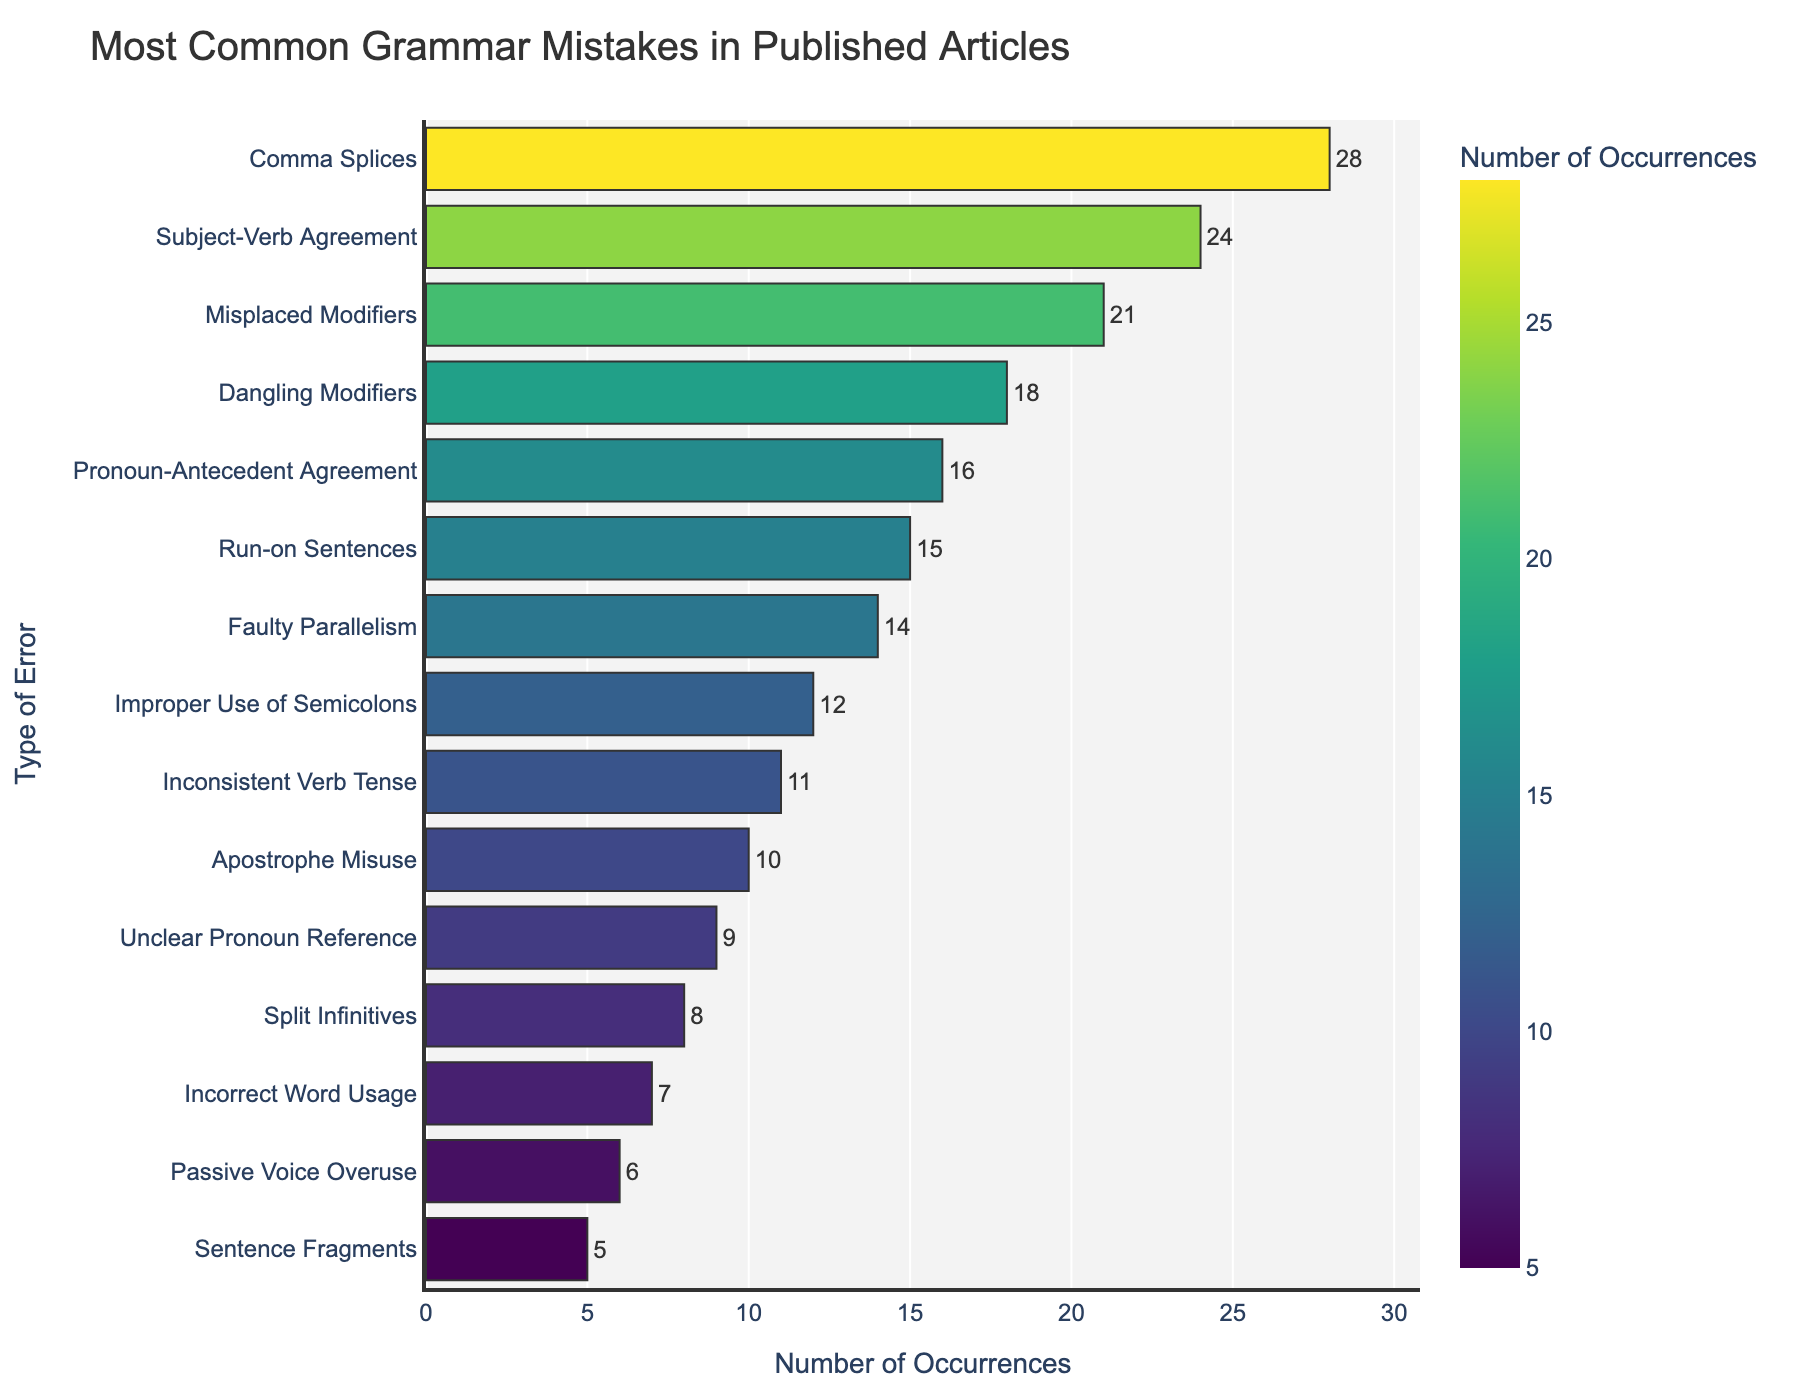What is the most common grammar mistake in published articles? The most common grammar mistake can be identified by looking at the bar with the highest frequency. The bar labeled "Comma Splices" has the highest value.
Answer: Comma Splices Which error types have a frequency greater than 20? Comparing all the frequencies to 20, the error types with frequencies greater than 20 are those where the bars exceed the 20 mark on the x-axis. These include "Comma Splices", "Subject-Verb Agreement", and "Misplaced Modifiers".
Answer: Comma Splices, Subject-Verb Agreement, Misplaced Modifiers What is the total frequency of the top three most common grammar mistakes? The top three most common grammar mistakes by frequency are "Comma Splices" (28), "Subject-Verb Agreement" (24), and "Misplaced Modifiers" (21). Summing these values gives 28 + 24 + 21 = 73.
Answer: 73 Which grammar mistake is the least common, and what is its frequency? The least common grammar mistake is represented by the shortest bar, which is "Sentence Fragments". Its frequency is 5.
Answer: Sentence Fragments, 5 Is the frequency of "Run-on Sentences" higher than "Improper Use of Semicolons"? By comparing the lengths of the bars for "Run-on Sentences" (15) and "Improper Use of Semicolons" (12), we can see that the frequency of "Run-on Sentences" is higher.
Answer: Yes How many grammar mistakes have a frequency less than 10? By counting the bars that end before the 10 mark on the x-axis, we find the error types: "Unclear Pronoun Reference", "Split Infinitives", "Incorrect Word Usage", "Passive Voice Overuse", and "Sentence Fragments". There are 5 error types.
Answer: 5 Which error type has a frequency that is closest to the median frequency value? To find the median, we need to order the frequencies and identify the middle value. With 15 values, the median is the 8th value when ordered. The sorted frequencies are: 5, 6, 7, 8, 9, 10, 11, 12, 14, 15, 16, 18, 21, 24, 28. The 8th value is "Improper Use of Semicolons" with a frequency of 12.
Answer: Improper Use of Semicolons Compare the frequencies of "Pronoun-Antecedent Agreement" and "Faulty Parallelism". Which one is higher and by how much? "Pronoun-Antecedent Agreement" has a frequency of 16 and "Faulty Parallelism" has a frequency of 14. The difference is 16 - 14 = 2.
Answer: Pronoun-Antecedent Agreement, by 2 What is the average frequency of the errors listed in the chart? Sum all the frequencies: 28 + 24 + 21 + 18 + 16 + 15 + 14 + 12 + 11 + 10 + 9 + 8 + 7 + 6 + 5 = 204. There are 15 error types. The average is 204 / 15 = 13.6
Answer: 13.6 